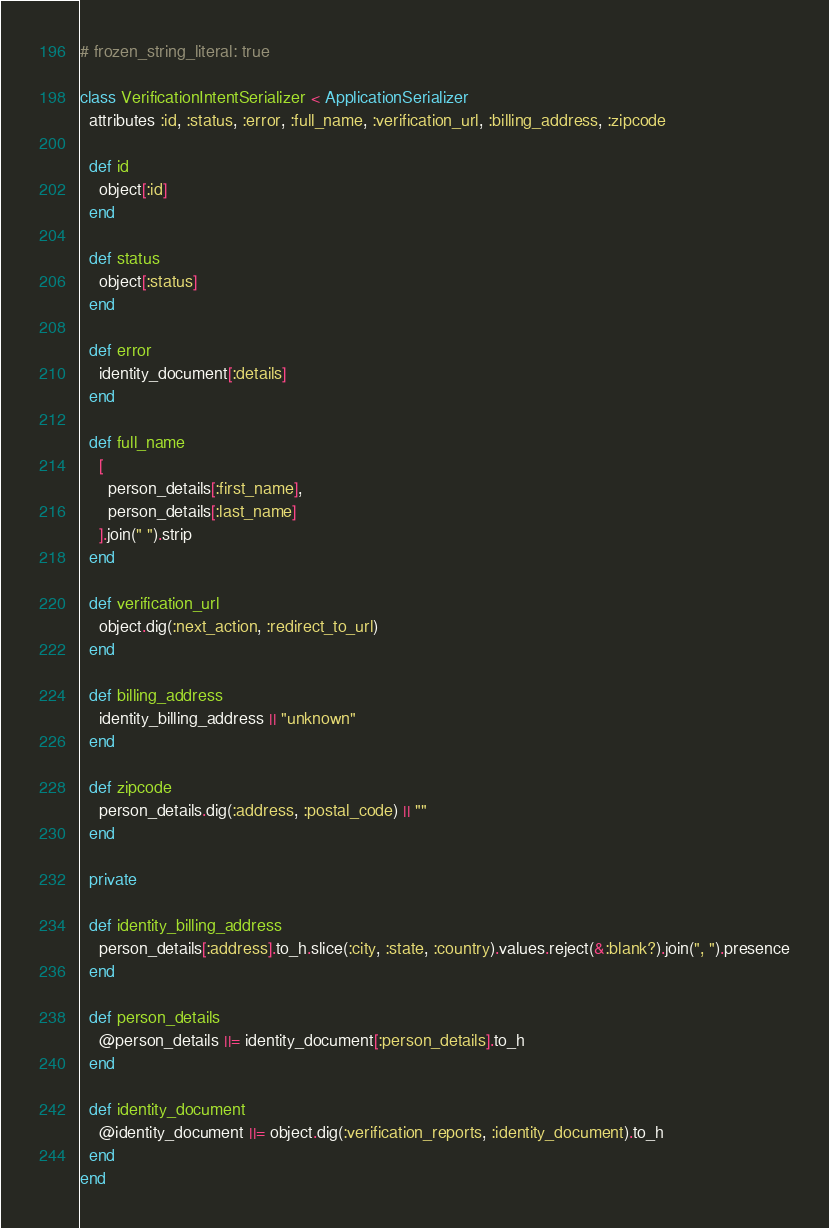Convert code to text. <code><loc_0><loc_0><loc_500><loc_500><_Ruby_># frozen_string_literal: true

class VerificationIntentSerializer < ApplicationSerializer
  attributes :id, :status, :error, :full_name, :verification_url, :billing_address, :zipcode

  def id
    object[:id]
  end

  def status
    object[:status]
  end

  def error
    identity_document[:details]
  end

  def full_name
    [
      person_details[:first_name],
      person_details[:last_name]
    ].join(" ").strip
  end

  def verification_url
    object.dig(:next_action, :redirect_to_url)
  end

  def billing_address
    identity_billing_address || "unknown"
  end

  def zipcode
    person_details.dig(:address, :postal_code) || ""
  end

  private

  def identity_billing_address
    person_details[:address].to_h.slice(:city, :state, :country).values.reject(&:blank?).join(", ").presence
  end

  def person_details
    @person_details ||= identity_document[:person_details].to_h
  end

  def identity_document
    @identity_document ||= object.dig(:verification_reports, :identity_document).to_h
  end
end
</code> 